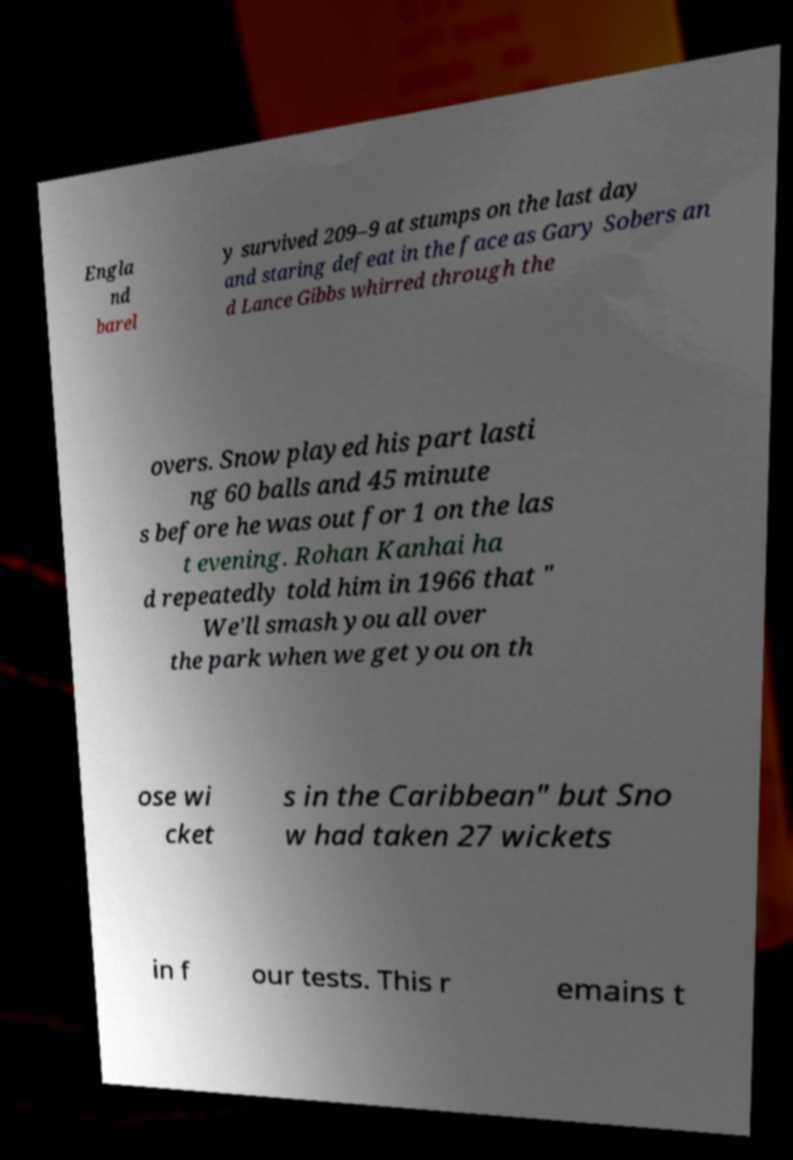There's text embedded in this image that I need extracted. Can you transcribe it verbatim? Engla nd barel y survived 209–9 at stumps on the last day and staring defeat in the face as Gary Sobers an d Lance Gibbs whirred through the overs. Snow played his part lasti ng 60 balls and 45 minute s before he was out for 1 on the las t evening. Rohan Kanhai ha d repeatedly told him in 1966 that " We'll smash you all over the park when we get you on th ose wi cket s in the Caribbean" but Sno w had taken 27 wickets in f our tests. This r emains t 